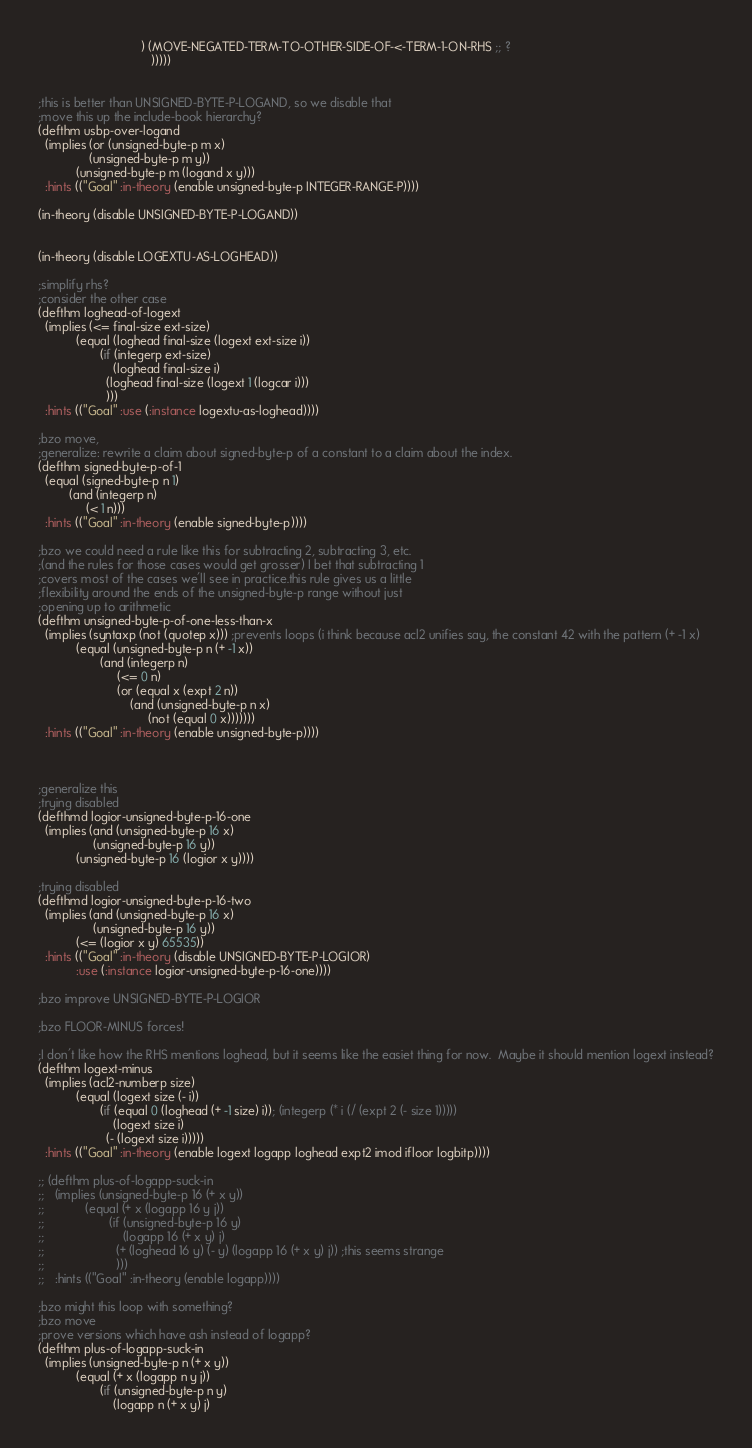Convert code to text. <code><loc_0><loc_0><loc_500><loc_500><_Lisp_>                              ) (MOVE-NEGATED-TERM-TO-OTHER-SIDE-OF-<-TERM-1-ON-RHS ;; ?
                                 )))))


;this is better than UNSIGNED-BYTE-P-LOGAND, so we disable that
;move this up the include-book hierarchy?
(defthm usbp-over-logand
  (implies (or (unsigned-byte-p m x)
               (unsigned-byte-p m y))
           (unsigned-byte-p m (logand x y)))
  :hints (("Goal" :in-theory (enable unsigned-byte-p INTEGER-RANGE-P))))

(in-theory (disable UNSIGNED-BYTE-P-LOGAND))


(in-theory (disable LOGEXTU-AS-LOGHEAD))

;simplify rhs?
;consider the other case
(defthm loghead-of-logext
  (implies (<= final-size ext-size)
           (equal (loghead final-size (logext ext-size i))
                  (if (integerp ext-size)
                      (loghead final-size i)
                    (loghead final-size (logext 1 (logcar i)))
                    )))
  :hints (("Goal" :use (:instance logextu-as-loghead))))

;bzo move,
;generalize: rewrite a claim about signed-byte-p of a constant to a claim about the index.
(defthm signed-byte-p-of-1
  (equal (signed-byte-p n 1)
         (and (integerp n)
              (< 1 n)))
  :hints (("Goal" :in-theory (enable signed-byte-p))))

;bzo we could need a rule like this for subtracting 2, subtracting 3, etc.
;(and the rules for those cases would get grosser) I bet that subtracting 1
;covers most of the cases we'll see in practice.this rule gives us a little
;flexibility around the ends of the unsigned-byte-p range without just
;opening up to arithmetic
(defthm unsigned-byte-p-of-one-less-than-x
  (implies (syntaxp (not (quotep x))) ;prevents loops (i think because acl2 unifies say, the constant 42 with the pattern (+ -1 x)
           (equal (unsigned-byte-p n (+ -1 x))
                  (and (integerp n)
                       (<= 0 n)
                       (or (equal x (expt 2 n))
                           (and (unsigned-byte-p n x)
                                (not (equal 0 x)))))))
  :hints (("Goal" :in-theory (enable unsigned-byte-p))))



;generalize this
;trying disabled
(defthmd logior-unsigned-byte-p-16-one
  (implies (and (unsigned-byte-p 16 x)
                (unsigned-byte-p 16 y))
           (unsigned-byte-p 16 (logior x y))))

;trying disabled
(defthmd logior-unsigned-byte-p-16-two
  (implies (and (unsigned-byte-p 16 x)
                (unsigned-byte-p 16 y))
           (<= (logior x y) 65535))
  :hints (("Goal" :in-theory (disable UNSIGNED-BYTE-P-LOGIOR)
           :use (:instance logior-unsigned-byte-p-16-one))))

;bzo improve UNSIGNED-BYTE-P-LOGIOR

;bzo FLOOR-MINUS forces!

;I don't like how the RHS mentions loghead, but it seems like the easiet thing for now.  Maybe it should mention logext instead?
(defthm logext-minus
  (implies (acl2-numberp size)
           (equal (logext size (- i))
                  (if (equal 0 (loghead (+ -1 size) i)); (integerp (* i (/ (expt 2 (- size 1)))))
                      (logext size i)
                    (- (logext size i)))))
  :hints (("Goal" :in-theory (enable logext logapp loghead expt2 imod ifloor logbitp))))

;; (defthm plus-of-logapp-suck-in
;;   (implies (unsigned-byte-p 16 (+ x y))
;;            (equal (+ x (logapp 16 y j))
;;                   (if (unsigned-byte-p 16 y)
;;                       (logapp 16 (+ x y) j)
;;                     (+ (loghead 16 y) (- y) (logapp 16 (+ x y) j)) ;this seems strange
;;                     )))
;;   :hints (("Goal" :in-theory (enable logapp))))

;bzo might this loop with something?
;bzo move
;prove versions which have ash instead of logapp?
(defthm plus-of-logapp-suck-in
  (implies (unsigned-byte-p n (+ x y))
           (equal (+ x (logapp n y j))
                  (if (unsigned-byte-p n y)
                      (logapp n (+ x y) j)</code> 